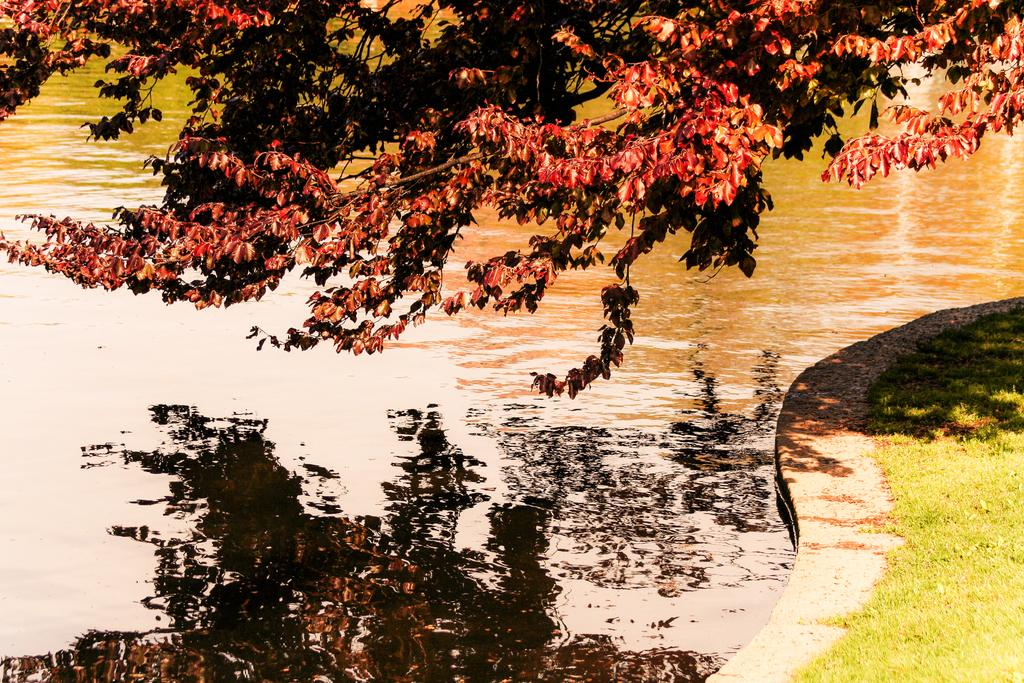What is the main element present in the image? There is water in the image. What can be seen above the water in the image? There are branches of a tree visible in the image. What type of vegetation is present on the ground in the image? There is grass on the ground in the image. What is the relationship between the branches of the tree and the water in the image? The branches of the tree are reflected in the water. Can you see a sail in the image? There is no sail present in the image. What type of pot is visible on the hill in the image? There is no hill or pot present in the image. 